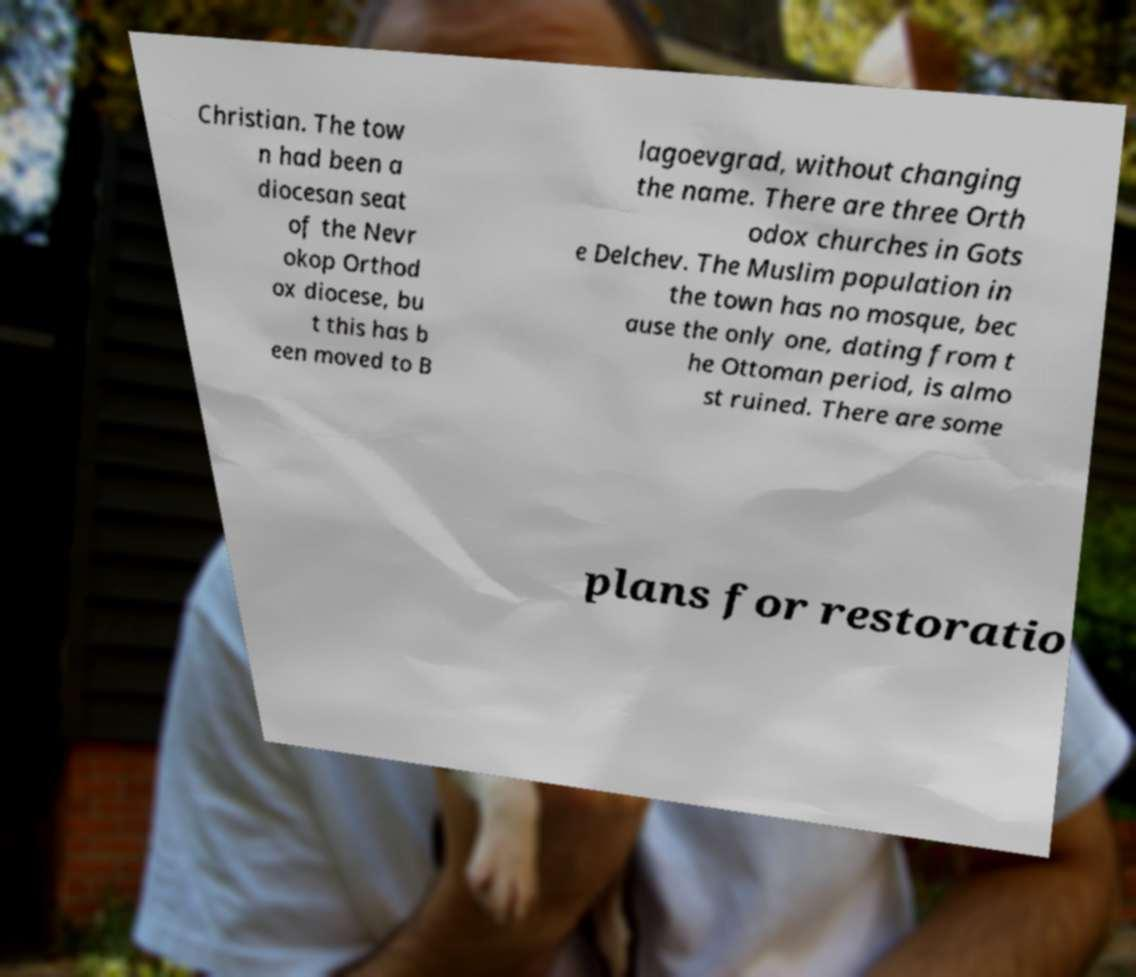There's text embedded in this image that I need extracted. Can you transcribe it verbatim? Christian. The tow n had been a diocesan seat of the Nevr okop Orthod ox diocese, bu t this has b een moved to B lagoevgrad, without changing the name. There are three Orth odox churches in Gots e Delchev. The Muslim population in the town has no mosque, bec ause the only one, dating from t he Ottoman period, is almo st ruined. There are some plans for restoratio 